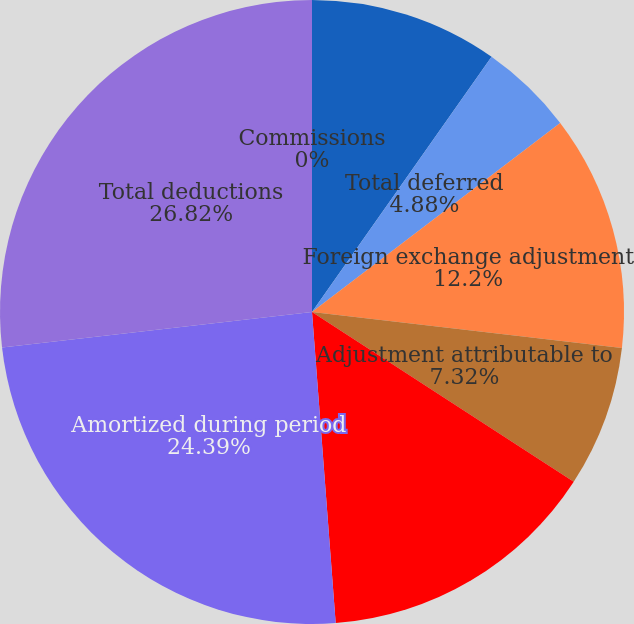<chart> <loc_0><loc_0><loc_500><loc_500><pie_chart><fcel>Commissions<fcel>Other expenses<fcel>Total deferred<fcel>Foreign exchange adjustment<fcel>Adjustment attributable to<fcel>Total additions<fcel>Amortized during period<fcel>Total deductions<nl><fcel>0.0%<fcel>9.76%<fcel>4.88%<fcel>12.2%<fcel>7.32%<fcel>14.63%<fcel>24.39%<fcel>26.82%<nl></chart> 